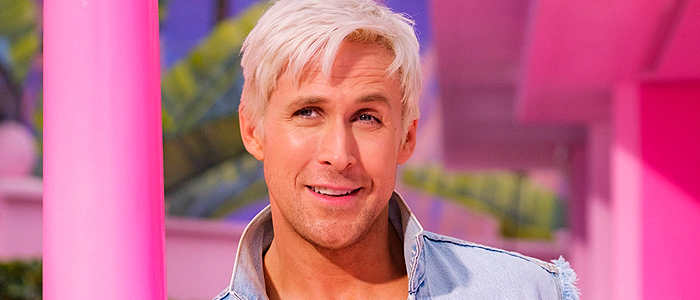What emotions do you think the man in the image is expressing? The man in the image seems to convey a sense of happiness and confidence, reflected through his slight smile and direct eye contact. His relaxed posture and the bright colors around him also contribute to a cheerful and inviting atmosphere. 